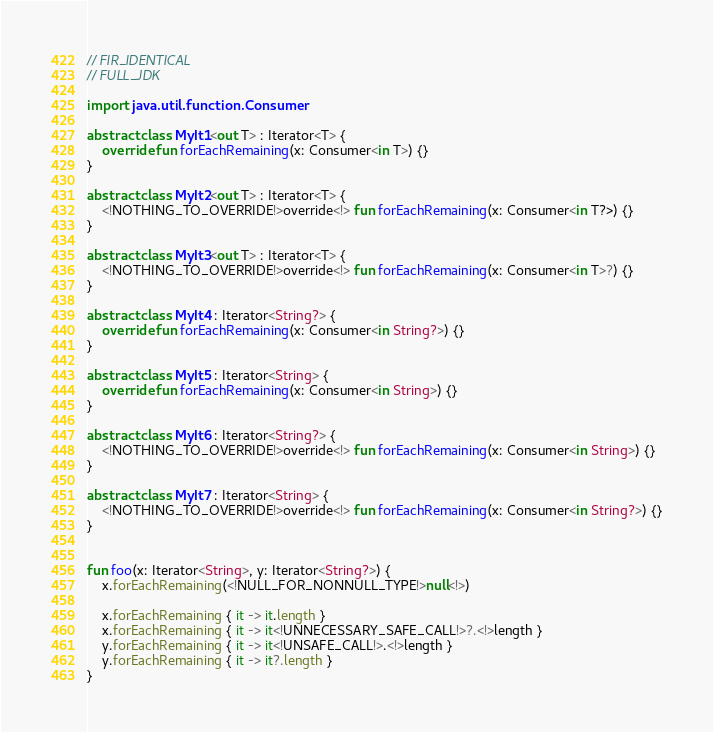Convert code to text. <code><loc_0><loc_0><loc_500><loc_500><_Kotlin_>// FIR_IDENTICAL
// FULL_JDK

import java.util.function.Consumer

abstract class MyIt1<out T> : Iterator<T> {
    override fun forEachRemaining(x: Consumer<in T>) {}
}

abstract class MyIt2<out T> : Iterator<T> {
    <!NOTHING_TO_OVERRIDE!>override<!> fun forEachRemaining(x: Consumer<in T?>) {}
}

abstract class MyIt3<out T> : Iterator<T> {
    <!NOTHING_TO_OVERRIDE!>override<!> fun forEachRemaining(x: Consumer<in T>?) {}
}

abstract class MyIt4 : Iterator<String?> {
    override fun forEachRemaining(x: Consumer<in String?>) {}
}

abstract class MyIt5 : Iterator<String> {
    override fun forEachRemaining(x: Consumer<in String>) {}
}

abstract class MyIt6 : Iterator<String?> {
    <!NOTHING_TO_OVERRIDE!>override<!> fun forEachRemaining(x: Consumer<in String>) {}
}

abstract class MyIt7 : Iterator<String> {
    <!NOTHING_TO_OVERRIDE!>override<!> fun forEachRemaining(x: Consumer<in String?>) {}
}


fun foo(x: Iterator<String>, y: Iterator<String?>) {
    x.forEachRemaining(<!NULL_FOR_NONNULL_TYPE!>null<!>)

    x.forEachRemaining { it -> it.length }
    x.forEachRemaining { it -> it<!UNNECESSARY_SAFE_CALL!>?.<!>length }
    y.forEachRemaining { it -> it<!UNSAFE_CALL!>.<!>length }
    y.forEachRemaining { it -> it?.length }
}
</code> 